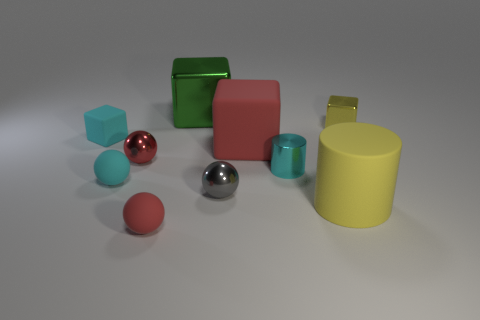Subtract 1 blocks. How many blocks are left? 3 Subtract all cylinders. How many objects are left? 8 Subtract all large matte objects. Subtract all small yellow shiny cubes. How many objects are left? 7 Add 4 tiny gray shiny spheres. How many tiny gray shiny spheres are left? 5 Add 5 tiny spheres. How many tiny spheres exist? 9 Subtract 0 gray cubes. How many objects are left? 10 